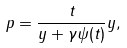<formula> <loc_0><loc_0><loc_500><loc_500>p = \frac { t } { \| y \| + \gamma \psi ( t ) } y ,</formula> 